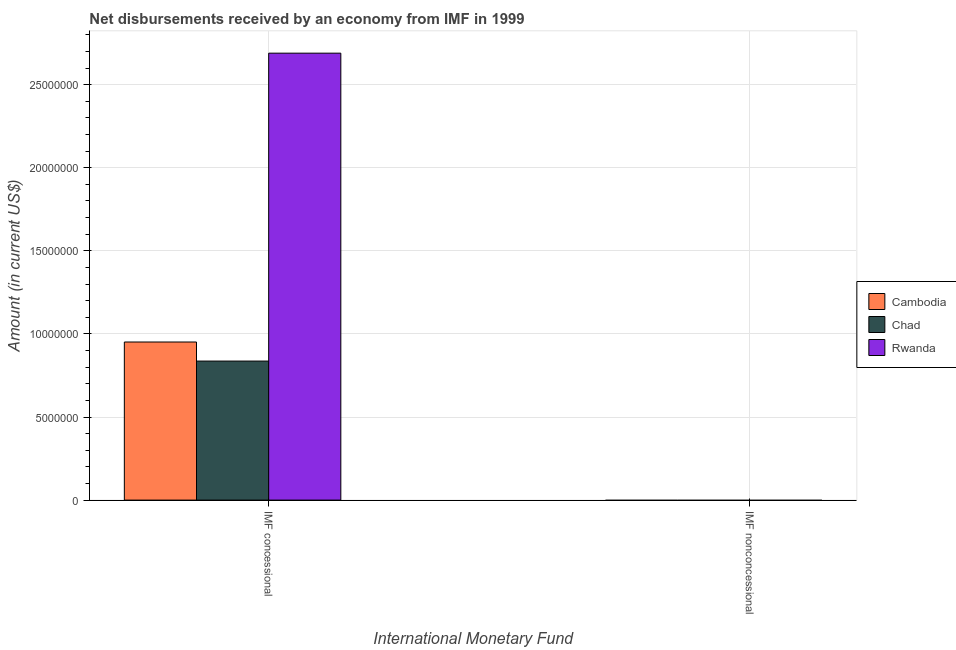Are the number of bars per tick equal to the number of legend labels?
Offer a very short reply. No. Are the number of bars on each tick of the X-axis equal?
Your answer should be compact. No. How many bars are there on the 2nd tick from the left?
Provide a short and direct response. 0. What is the label of the 2nd group of bars from the left?
Give a very brief answer. IMF nonconcessional. What is the net concessional disbursements from imf in Cambodia?
Ensure brevity in your answer.  9.51e+06. Across all countries, what is the maximum net concessional disbursements from imf?
Your answer should be compact. 2.69e+07. Across all countries, what is the minimum net concessional disbursements from imf?
Ensure brevity in your answer.  8.37e+06. In which country was the net concessional disbursements from imf maximum?
Ensure brevity in your answer.  Rwanda. What is the difference between the net concessional disbursements from imf in Cambodia and that in Chad?
Your response must be concise. 1.15e+06. What is the difference between the net non concessional disbursements from imf in Chad and the net concessional disbursements from imf in Cambodia?
Ensure brevity in your answer.  -9.51e+06. What is the average net concessional disbursements from imf per country?
Make the answer very short. 1.49e+07. What is the ratio of the net concessional disbursements from imf in Chad to that in Cambodia?
Ensure brevity in your answer.  0.88. Are the values on the major ticks of Y-axis written in scientific E-notation?
Offer a terse response. No. Does the graph contain grids?
Give a very brief answer. Yes. Where does the legend appear in the graph?
Give a very brief answer. Center right. How are the legend labels stacked?
Keep it short and to the point. Vertical. What is the title of the graph?
Your response must be concise. Net disbursements received by an economy from IMF in 1999. What is the label or title of the X-axis?
Make the answer very short. International Monetary Fund. What is the Amount (in current US$) in Cambodia in IMF concessional?
Offer a terse response. 9.51e+06. What is the Amount (in current US$) in Chad in IMF concessional?
Offer a very short reply. 8.37e+06. What is the Amount (in current US$) of Rwanda in IMF concessional?
Keep it short and to the point. 2.69e+07. What is the Amount (in current US$) in Cambodia in IMF nonconcessional?
Your response must be concise. 0. What is the Amount (in current US$) of Rwanda in IMF nonconcessional?
Offer a very short reply. 0. Across all International Monetary Fund, what is the maximum Amount (in current US$) in Cambodia?
Make the answer very short. 9.51e+06. Across all International Monetary Fund, what is the maximum Amount (in current US$) of Chad?
Provide a short and direct response. 8.37e+06. Across all International Monetary Fund, what is the maximum Amount (in current US$) in Rwanda?
Offer a very short reply. 2.69e+07. Across all International Monetary Fund, what is the minimum Amount (in current US$) of Cambodia?
Offer a very short reply. 0. What is the total Amount (in current US$) of Cambodia in the graph?
Provide a succinct answer. 9.51e+06. What is the total Amount (in current US$) of Chad in the graph?
Offer a very short reply. 8.37e+06. What is the total Amount (in current US$) in Rwanda in the graph?
Ensure brevity in your answer.  2.69e+07. What is the average Amount (in current US$) of Cambodia per International Monetary Fund?
Ensure brevity in your answer.  4.76e+06. What is the average Amount (in current US$) of Chad per International Monetary Fund?
Offer a terse response. 4.18e+06. What is the average Amount (in current US$) in Rwanda per International Monetary Fund?
Offer a terse response. 1.34e+07. What is the difference between the Amount (in current US$) of Cambodia and Amount (in current US$) of Chad in IMF concessional?
Your answer should be compact. 1.15e+06. What is the difference between the Amount (in current US$) in Cambodia and Amount (in current US$) in Rwanda in IMF concessional?
Your response must be concise. -1.74e+07. What is the difference between the Amount (in current US$) in Chad and Amount (in current US$) in Rwanda in IMF concessional?
Keep it short and to the point. -1.85e+07. What is the difference between the highest and the lowest Amount (in current US$) of Cambodia?
Provide a short and direct response. 9.51e+06. What is the difference between the highest and the lowest Amount (in current US$) of Chad?
Give a very brief answer. 8.37e+06. What is the difference between the highest and the lowest Amount (in current US$) of Rwanda?
Your answer should be compact. 2.69e+07. 